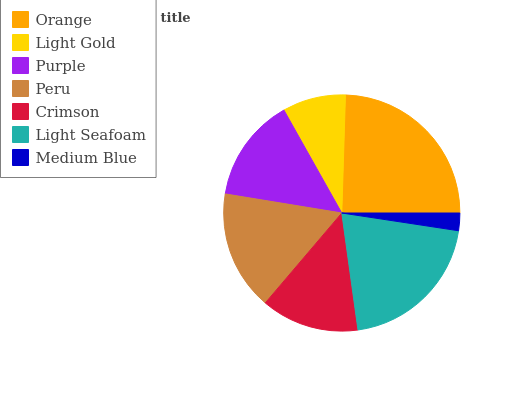Is Medium Blue the minimum?
Answer yes or no. Yes. Is Orange the maximum?
Answer yes or no. Yes. Is Light Gold the minimum?
Answer yes or no. No. Is Light Gold the maximum?
Answer yes or no. No. Is Orange greater than Light Gold?
Answer yes or no. Yes. Is Light Gold less than Orange?
Answer yes or no. Yes. Is Light Gold greater than Orange?
Answer yes or no. No. Is Orange less than Light Gold?
Answer yes or no. No. Is Purple the high median?
Answer yes or no. Yes. Is Purple the low median?
Answer yes or no. Yes. Is Light Seafoam the high median?
Answer yes or no. No. Is Light Gold the low median?
Answer yes or no. No. 